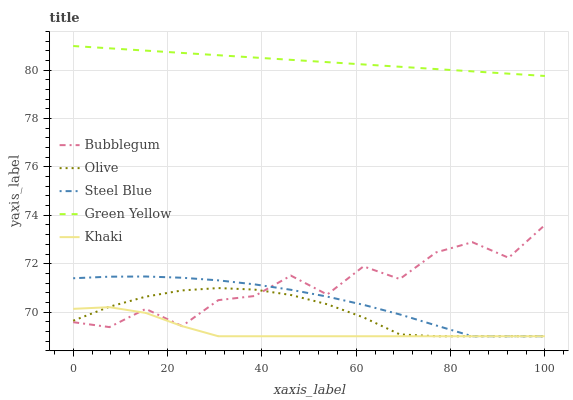Does Khaki have the minimum area under the curve?
Answer yes or no. Yes. Does Green Yellow have the maximum area under the curve?
Answer yes or no. Yes. Does Green Yellow have the minimum area under the curve?
Answer yes or no. No. Does Khaki have the maximum area under the curve?
Answer yes or no. No. Is Green Yellow the smoothest?
Answer yes or no. Yes. Is Bubblegum the roughest?
Answer yes or no. Yes. Is Khaki the smoothest?
Answer yes or no. No. Is Khaki the roughest?
Answer yes or no. No. Does Olive have the lowest value?
Answer yes or no. Yes. Does Green Yellow have the lowest value?
Answer yes or no. No. Does Green Yellow have the highest value?
Answer yes or no. Yes. Does Khaki have the highest value?
Answer yes or no. No. Is Khaki less than Green Yellow?
Answer yes or no. Yes. Is Green Yellow greater than Khaki?
Answer yes or no. Yes. Does Khaki intersect Steel Blue?
Answer yes or no. Yes. Is Khaki less than Steel Blue?
Answer yes or no. No. Is Khaki greater than Steel Blue?
Answer yes or no. No. Does Khaki intersect Green Yellow?
Answer yes or no. No. 